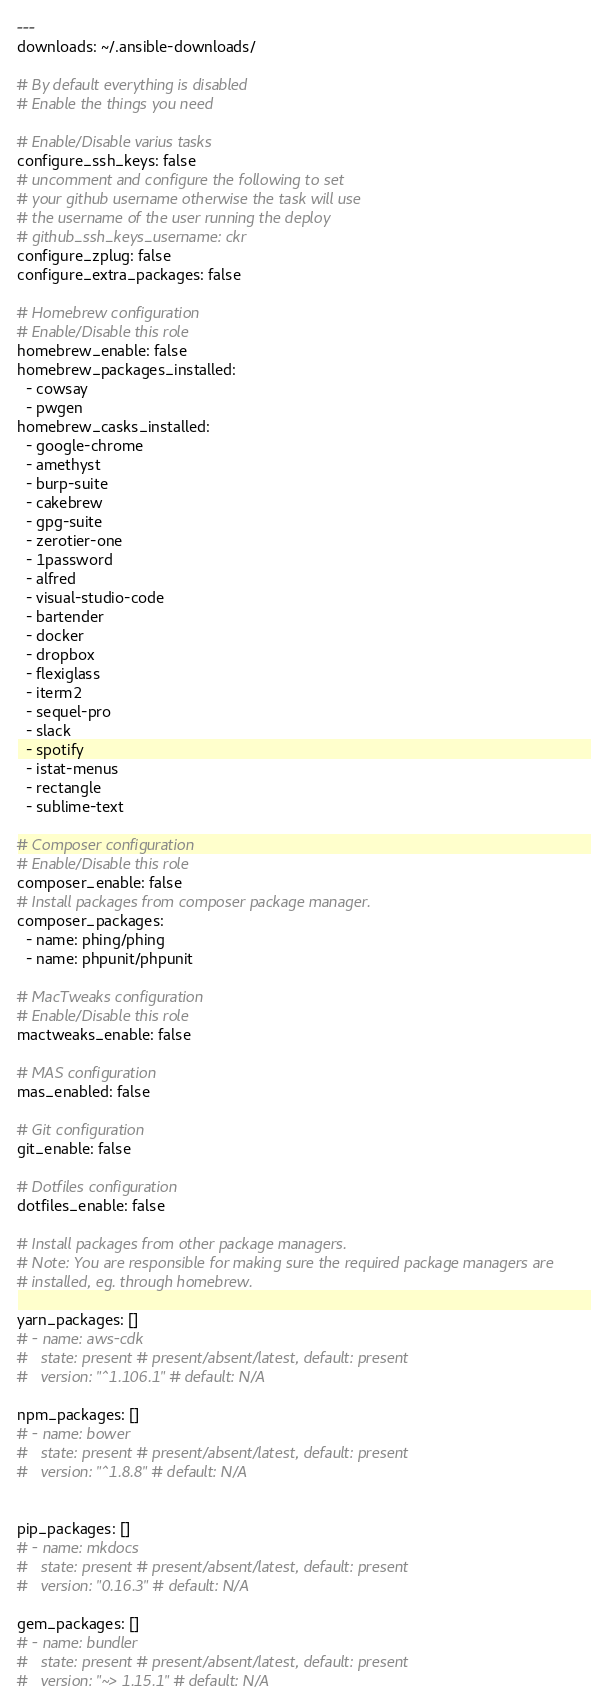Convert code to text. <code><loc_0><loc_0><loc_500><loc_500><_YAML_>---
downloads: ~/.ansible-downloads/

# By default everything is disabled
# Enable the things you need

# Enable/Disable varius tasks
configure_ssh_keys: false
# uncomment and configure the following to set
# your github username otherwise the task will use
# the username of the user running the deploy
# github_ssh_keys_username: ckr
configure_zplug: false
configure_extra_packages: false

# Homebrew configuration
# Enable/Disable this role
homebrew_enable: false
homebrew_packages_installed:
  - cowsay
  - pwgen
homebrew_casks_installed:
  - google-chrome
  - amethyst
  - burp-suite
  - cakebrew
  - gpg-suite
  - zerotier-one
  - 1password
  - alfred
  - visual-studio-code
  - bartender
  - docker
  - dropbox
  - flexiglass
  - iterm2
  - sequel-pro
  - slack
  - spotify
  - istat-menus
  - rectangle
  - sublime-text

# Composer configuration
# Enable/Disable this role
composer_enable: false
# Install packages from composer package manager.
composer_packages:
  - name: phing/phing
  - name: phpunit/phpunit

# MacTweaks configuration
# Enable/Disable this role
mactweaks_enable: false

# MAS configuration
mas_enabled: false

# Git configuration
git_enable: false

# Dotfiles configuration
dotfiles_enable: false

# Install packages from other package managers.
# Note: You are responsible for making sure the required package managers are
# installed, eg. through homebrew.

yarn_packages: []
# - name: aws-cdk
#   state: present # present/absent/latest, default: present
#   version: "^1.106.1" # default: N/A

npm_packages: []
# - name: bower
#   state: present # present/absent/latest, default: present
#   version: "^1.8.8" # default: N/A


pip_packages: []
# - name: mkdocs
#   state: present # present/absent/latest, default: present
#   version: "0.16.3" # default: N/A

gem_packages: []
# - name: bundler
#   state: present # present/absent/latest, default: present
#   version: "~> 1.15.1" # default: N/A
</code> 